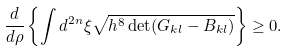<formula> <loc_0><loc_0><loc_500><loc_500>\frac { d } { d \rho } \left \{ \int d ^ { 2 n } \xi \sqrt { h ^ { 8 } \det ( G _ { k l } - B _ { k l } ) } \right \} \geq 0 .</formula> 